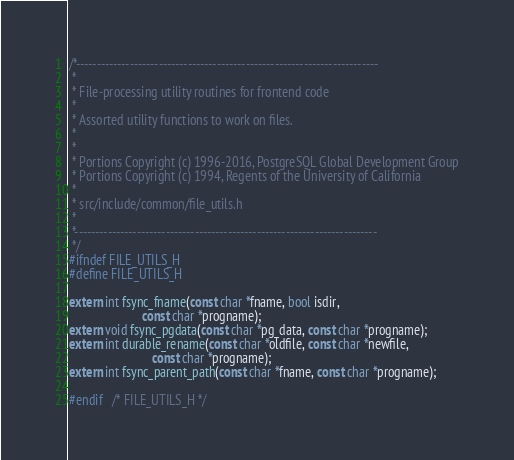<code> <loc_0><loc_0><loc_500><loc_500><_C_>/*-------------------------------------------------------------------------
 *
 * File-processing utility routines for frontend code
 *
 * Assorted utility functions to work on files.
 *
 *
 * Portions Copyright (c) 1996-2016, PostgreSQL Global Development Group
 * Portions Copyright (c) 1994, Regents of the University of California
 *
 * src/include/common/file_utils.h
 *
 *-------------------------------------------------------------------------
 */
#ifndef FILE_UTILS_H
#define FILE_UTILS_H

extern int fsync_fname(const char *fname, bool isdir,
					   const char *progname);
extern void fsync_pgdata(const char *pg_data, const char *progname);
extern int durable_rename(const char *oldfile, const char *newfile,
						  const char *progname);
extern int fsync_parent_path(const char *fname, const char *progname);

#endif   /* FILE_UTILS_H */
</code> 